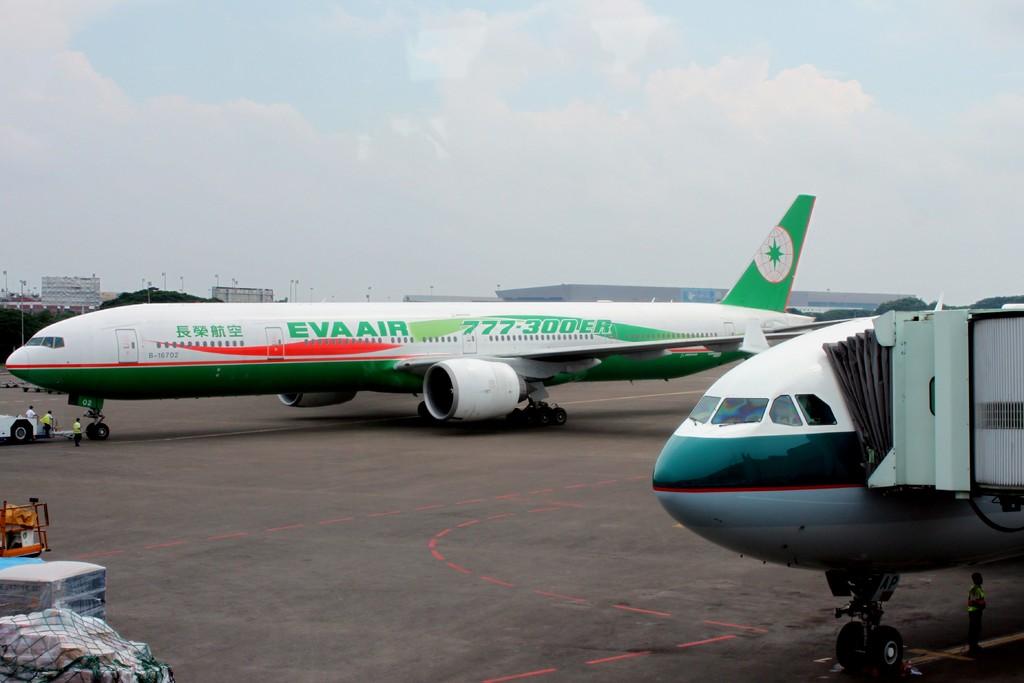What is the airline this plane belongs to?
Your answer should be very brief. Eva air. What is the 6 digit numbers on the side of the plane?
Provide a short and direct response. 777-300. 